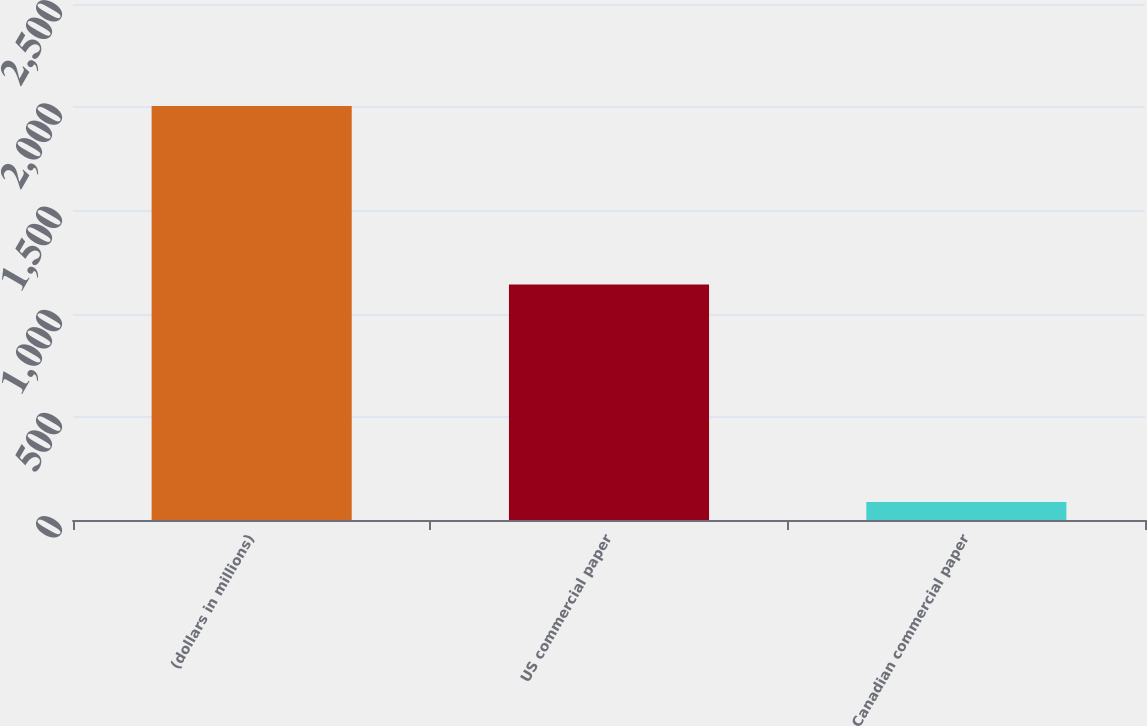<chart> <loc_0><loc_0><loc_500><loc_500><bar_chart><fcel>(dollars in millions)<fcel>US commercial paper<fcel>Canadian commercial paper<nl><fcel>2006<fcel>1140.7<fcel>87.5<nl></chart> 